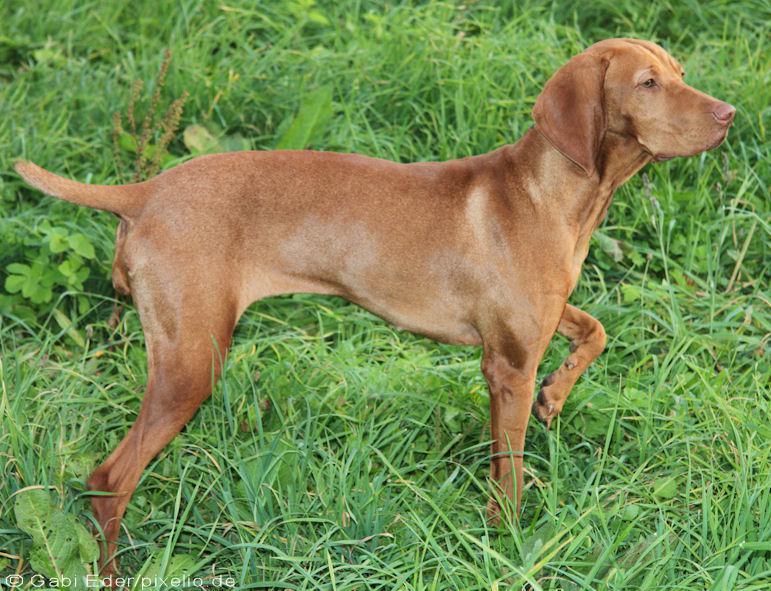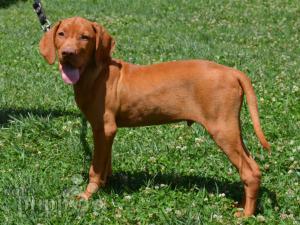The first image is the image on the left, the second image is the image on the right. Considering the images on both sides, is "The dog in the image on the right is on a leash." valid? Answer yes or no. Yes. The first image is the image on the left, the second image is the image on the right. For the images displayed, is the sentence "One image shows a dog standing in profile with its body turned leftward, and the other image shows a dog standing with its body turned rightward and with one front paw raised." factually correct? Answer yes or no. Yes. 